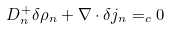<formula> <loc_0><loc_0><loc_500><loc_500>D _ { n } ^ { + } \delta \rho _ { n } + \nabla \cdot \delta { j } _ { n } = _ { c } 0</formula> 